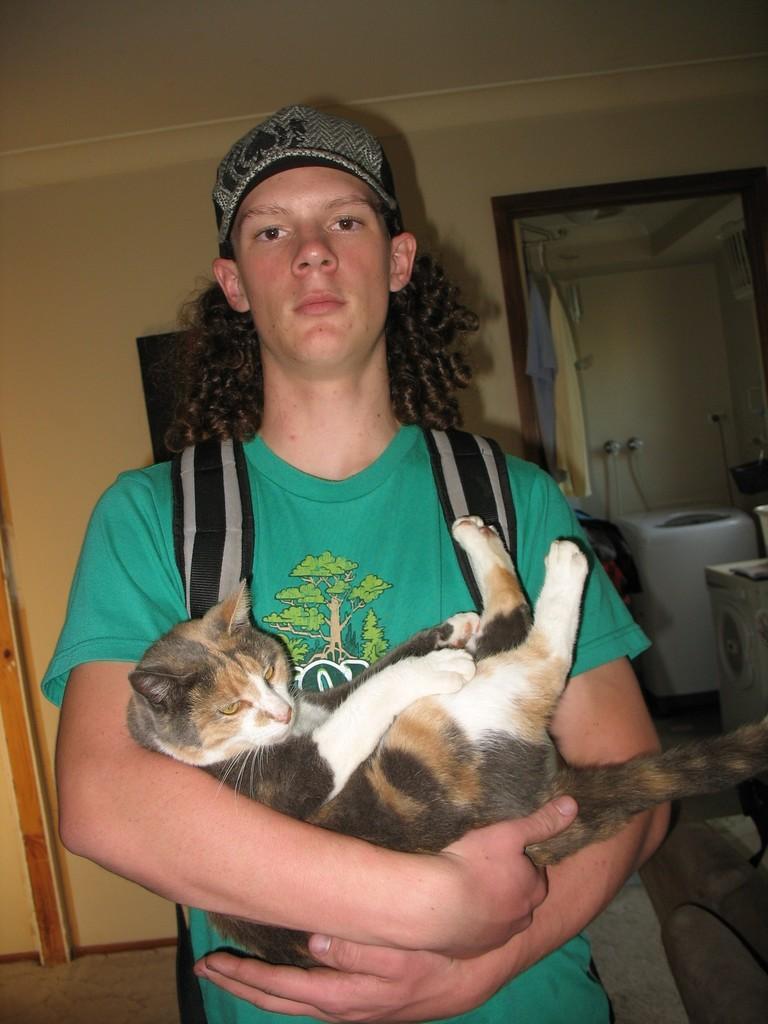Describe this image in one or two sentences. In the middle of the image we can see a man, he wore a cap and a bag, and he is holding a cat, behind to him we can see few machines and clothes, and also we can see a frame on the wall. 